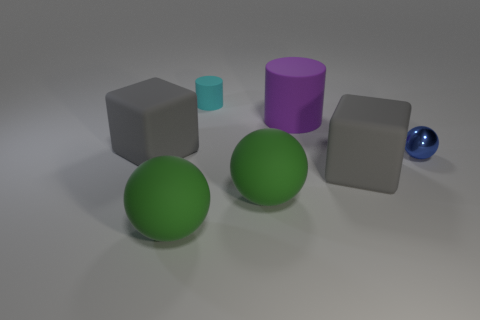Add 3 gray things. How many objects exist? 10 Subtract all spheres. How many objects are left? 4 Subtract 0 cyan spheres. How many objects are left? 7 Subtract all green metal cylinders. Subtract all cyan rubber things. How many objects are left? 6 Add 6 green spheres. How many green spheres are left? 8 Add 7 small things. How many small things exist? 9 